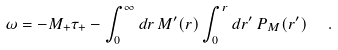Convert formula to latex. <formula><loc_0><loc_0><loc_500><loc_500>\omega = - M _ { + } \tau _ { + } - \int _ { 0 } ^ { \infty } d r \, M ^ { \prime } ( r ) \int _ { 0 } ^ { r } d r ^ { \prime } \, P _ { M } ( r ^ { \prime } ) \ \ .</formula> 